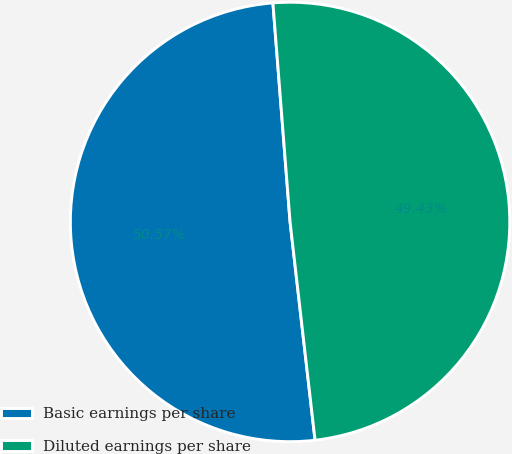<chart> <loc_0><loc_0><loc_500><loc_500><pie_chart><fcel>Basic earnings per share<fcel>Diluted earnings per share<nl><fcel>50.57%<fcel>49.43%<nl></chart> 